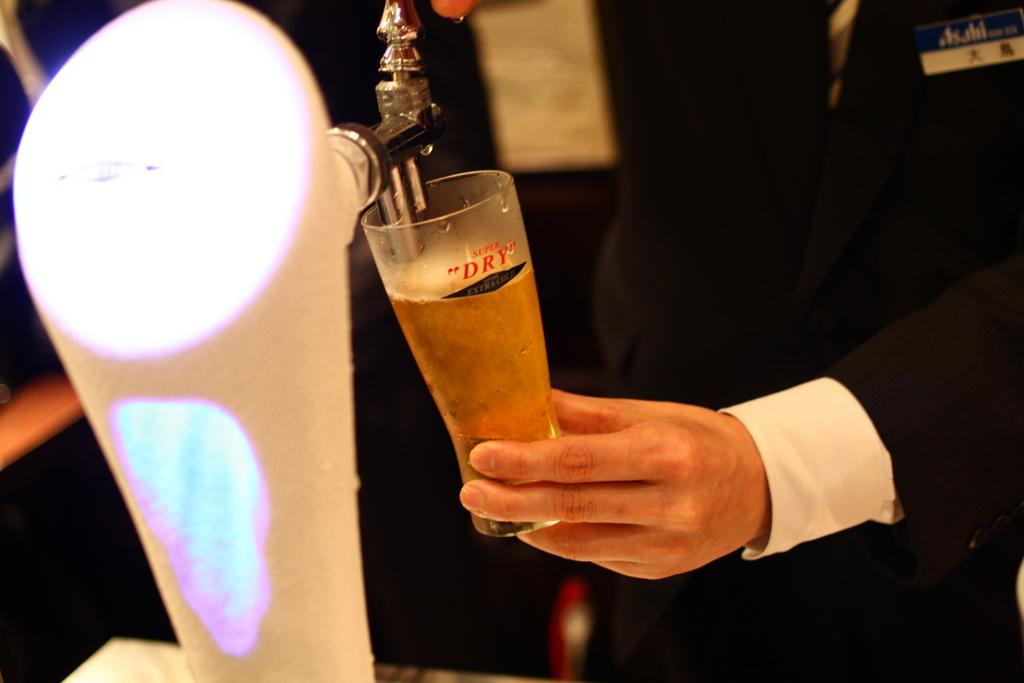<image>
Render a clear and concise summary of the photo. The beer being served is super dry beer. 